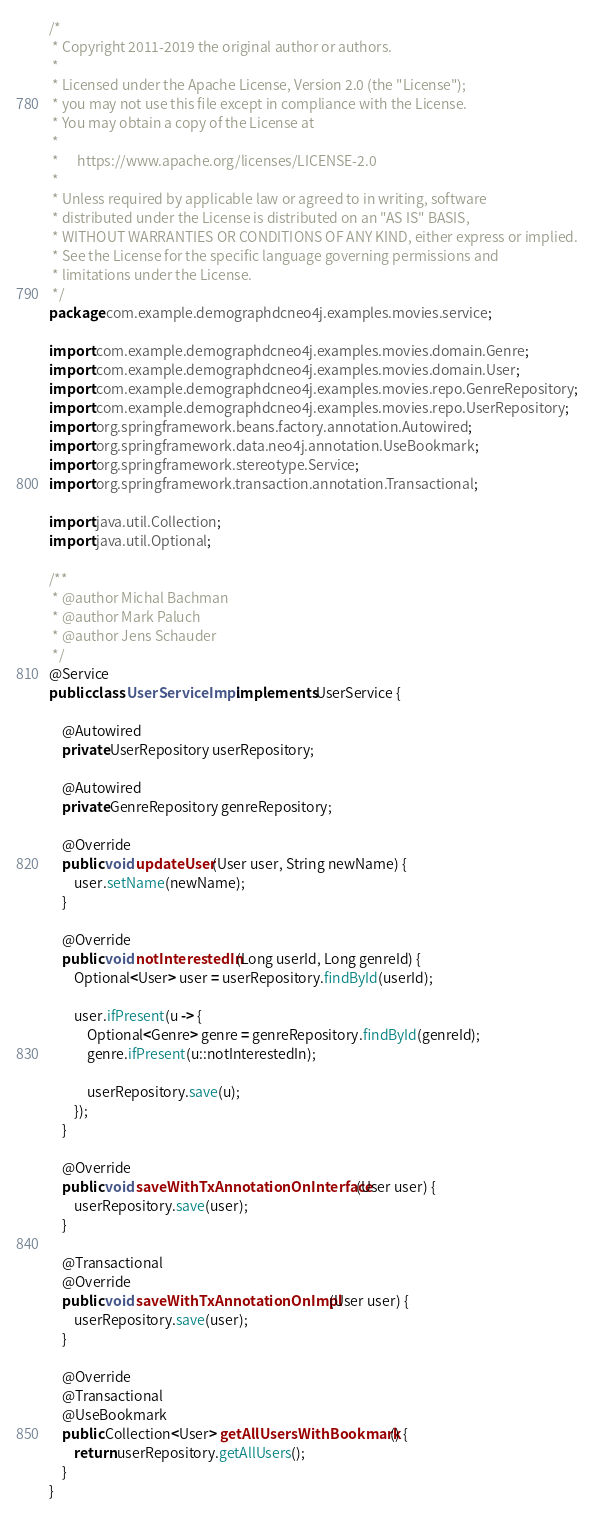<code> <loc_0><loc_0><loc_500><loc_500><_Java_>/*
 * Copyright 2011-2019 the original author or authors.
 *
 * Licensed under the Apache License, Version 2.0 (the "License");
 * you may not use this file except in compliance with the License.
 * You may obtain a copy of the License at
 *
 *      https://www.apache.org/licenses/LICENSE-2.0
 *
 * Unless required by applicable law or agreed to in writing, software
 * distributed under the License is distributed on an "AS IS" BASIS,
 * WITHOUT WARRANTIES OR CONDITIONS OF ANY KIND, either express or implied.
 * See the License for the specific language governing permissions and
 * limitations under the License.
 */
package com.example.demographdcneo4j.examples.movies.service;

import com.example.demographdcneo4j.examples.movies.domain.Genre;
import com.example.demographdcneo4j.examples.movies.domain.User;
import com.example.demographdcneo4j.examples.movies.repo.GenreRepository;
import com.example.demographdcneo4j.examples.movies.repo.UserRepository;
import org.springframework.beans.factory.annotation.Autowired;
import org.springframework.data.neo4j.annotation.UseBookmark;
import org.springframework.stereotype.Service;
import org.springframework.transaction.annotation.Transactional;

import java.util.Collection;
import java.util.Optional;

/**
 * @author Michal Bachman
 * @author Mark Paluch
 * @author Jens Schauder
 */
@Service
public class UserServiceImpl implements UserService {

	@Autowired
    private UserRepository userRepository;

	@Autowired
    private GenreRepository genreRepository;

	@Override
	public void updateUser(User user, String newName) {
		user.setName(newName);
	}

	@Override
	public void notInterestedIn(Long userId, Long genreId) {
		Optional<User> user = userRepository.findById(userId);

		user.ifPresent(u -> {
			Optional<Genre> genre = genreRepository.findById(genreId);
			genre.ifPresent(u::notInterestedIn);

			userRepository.save(u);
		});
	}

	@Override
	public void saveWithTxAnnotationOnInterface(User user) {
		userRepository.save(user);
	}

	@Transactional
	@Override
	public void saveWithTxAnnotationOnImpl(User user) {
		userRepository.save(user);
	}

	@Override
	@Transactional
	@UseBookmark
	public Collection<User> getAllUsersWithBookmark() {
		return userRepository.getAllUsers();
	}
}
</code> 